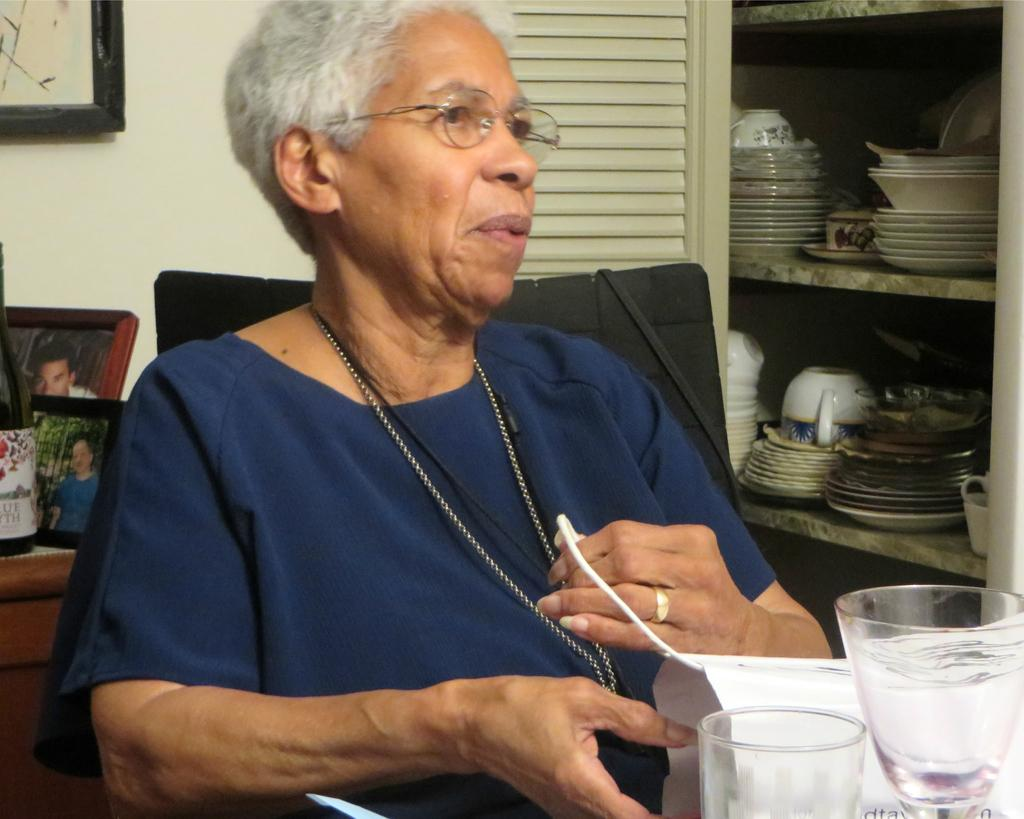Who is the main subject in the image? There is a lady in the image. What is the lady doing in the image? The lady is sitting on a chair. What is the lady wearing in the image? The lady is wearing a blue dress. What can be seen in the background of the image? There is a wall and a shelf with objects in the background of the image. How does the lady treat her wound in the image? There is no wound present in the image, so it cannot be treated. 